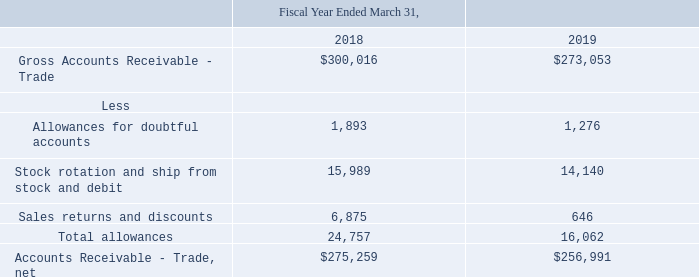5. Trade Accounts Receivable and Contract Liabilities:
Charges related to allowances for doubtful accounts are charged to selling, general, and administrative expenses. Charges related to stock rotation, ship from stock and debit, sales returns, and sales discounts are reported as deductions from revenue. Please refer to Note 6, “Revenue Recognition,” for additional information
Where are charges related to allowances for doubtful accounts are charged to? Charged to selling, general, and administrative expenses. Where are charges related to stock rotation, ship from stock and debit, sales returns, and sales discounts are reported as? Reported as deductions from revenue. What is the company's allowances for doubtful accounts in 2019? 1,276. What is the total allowances for doubtful accounts in 2018 and 2019? 1,893 + 1,276 
Answer: 3169. What is the percentage change in net accounts receivable - trade between 2018 and 2019?
Answer scale should be: percent. (256,991 - 275,259)/275,259 
Answer: -6.64. What is the total allowances in 2018 as a percentage of the gross accounts receivable - trade?
Answer scale should be: percent. 24,757/300,016 
Answer: 8.25. 